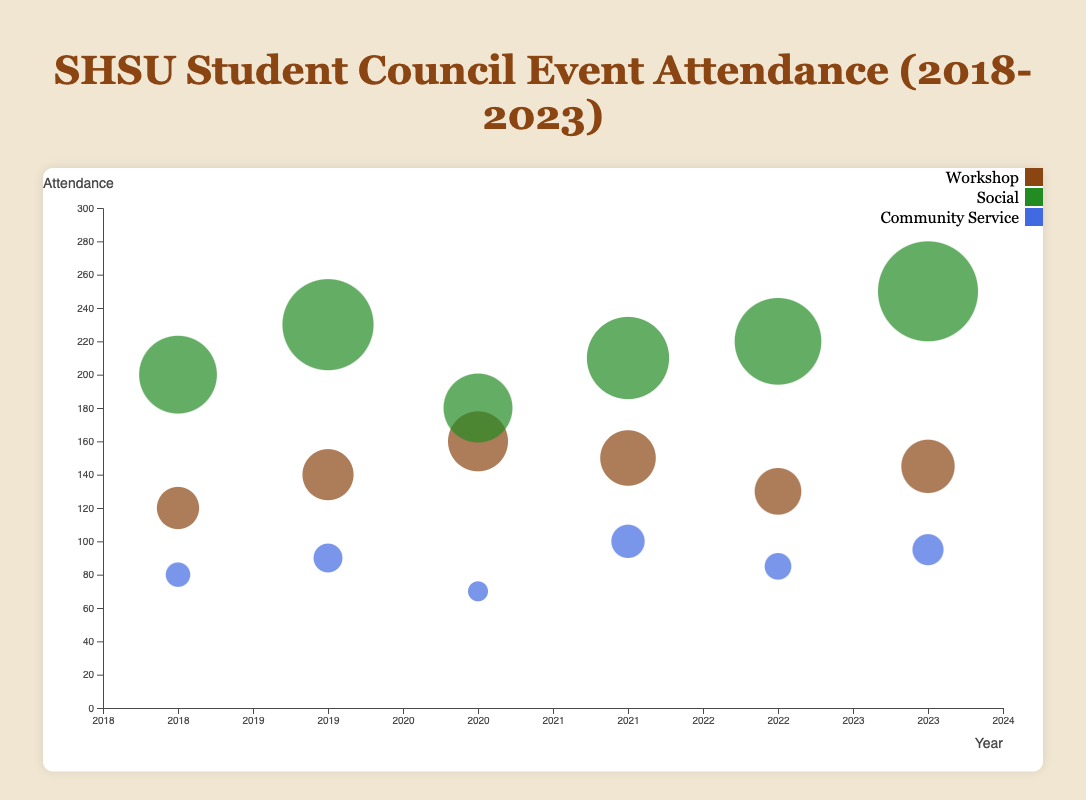How many types of events are represented in the chart? The legend at the side of the chart shows different colors for event types. By counting the unique colors, we can determine the number of types of events.
Answer: 3 What is the title of the chart? The title is located at the top of the chart and reads as given in the dataset.
Answer: SHSU Student Council Event Attendance (2018-2023) Which event had the highest attendance in 2023? Locate the events for the year 2023 and compare the bubble sizes, as larger bubble sizes represent higher attendance.
Answer: Sports Day What are the axis labels on the chart? The x-axis label is below the horizontal axis and the y-axis label is next to the vertical axis.
Answer: Year (x-axis), Attendance (y-axis) Which year had the highest overall event attendance? Sum up the attendance for all events in each year and compare the totals.
Answer: 2023 How much more attendance did the 2023 "Sports Day" have compared to the 2022 "Summer BBQ"? Determine the attendance for each event (250 for Sports Day and 220 for Summer BBQ) and calculate the difference.
Answer: 30 What was the attendance for the "Career Planning" workshop in 2020? Locate the year 2020 and the type "Workshop," then identify the specific event bubble.
Answer: 160 How does the attendance for the 2019 "Homecoming Dance" compare to the overall average attendance for all events in 2019? Calculate the average attendance for all 2019 events and compare it to the specific event. Perform the sum (140 + 230 + 90 = 460) and divide by 3 (460 / 3 = ~153.33). Comparing 230 with 153.33.
Answer: Homecoming Dance had higher attendance than the average What is the color code for social events in the chart? Check the legend and identify the color corresponding to "Social".
Answer: Green Which type of event saw the most significant increase in attendance over the years? Compare attendance trends for each event type year-by-year and identify the largest increase. Workshop saw a consistent increase across the years.
Answer: Workshop 